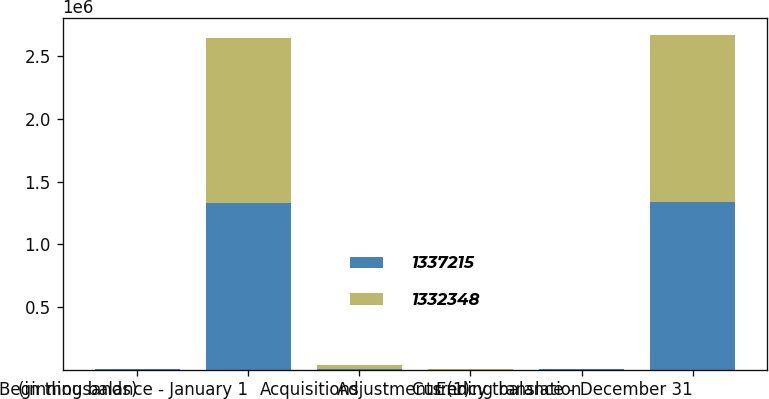<chart> <loc_0><loc_0><loc_500><loc_500><stacked_bar_chart><ecel><fcel>(in thousands)<fcel>Beginning balance - January 1<fcel>Acquisitions<fcel>Adjustments (1)<fcel>Currency translation<fcel>Ending balance - December 31<nl><fcel>1.33722e+06<fcel>2016<fcel>1.33235e+06<fcel>6184<fcel>1<fcel>1316<fcel>1.33722e+06<nl><fcel>1.33235e+06<fcel>2015<fcel>1.31218e+06<fcel>28561<fcel>4573<fcel>3822<fcel>1.33235e+06<nl></chart> 